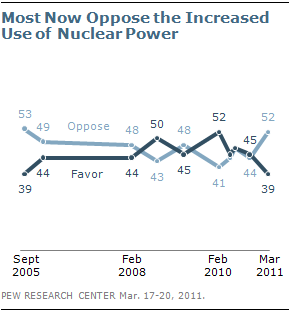Point out several critical features in this image. For the past 5 years, the outlook for the opposing view has been more favorable than the favorable view. The peak percentage of opposition is reached when 44444 is... 